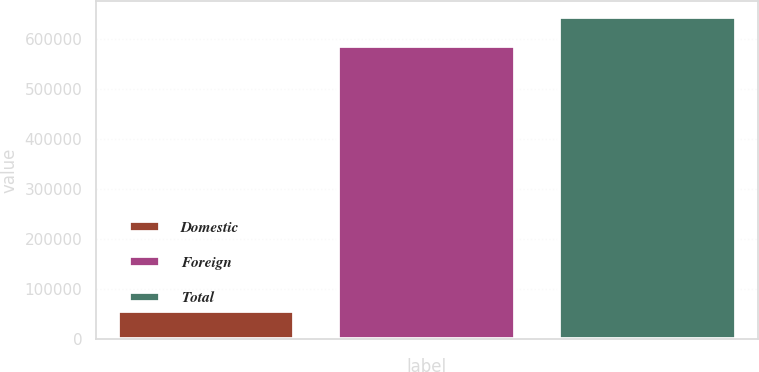Convert chart to OTSL. <chart><loc_0><loc_0><loc_500><loc_500><bar_chart><fcel>Domestic<fcel>Foreign<fcel>Total<nl><fcel>55751<fcel>585346<fcel>643881<nl></chart> 